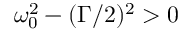<formula> <loc_0><loc_0><loc_500><loc_500>\omega _ { 0 } ^ { 2 } - ( \Gamma / 2 ) ^ { 2 } > 0</formula> 